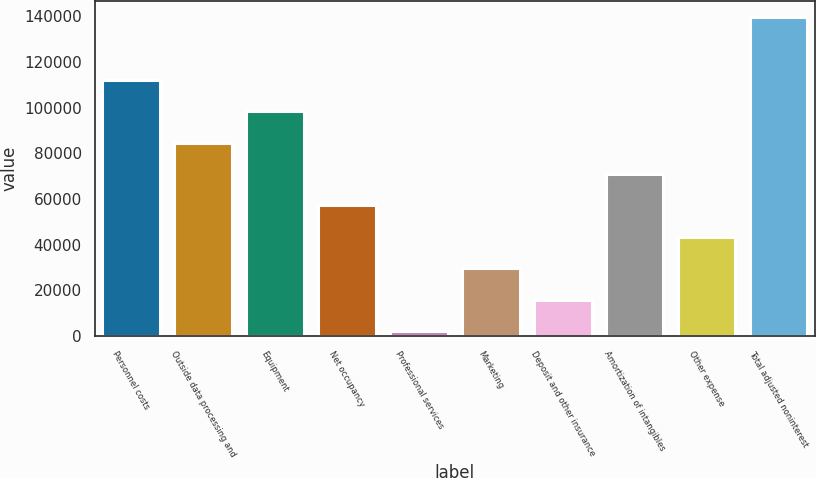Convert chart. <chart><loc_0><loc_0><loc_500><loc_500><bar_chart><fcel>Personnel costs<fcel>Outside data processing and<fcel>Equipment<fcel>Net occupancy<fcel>Professional services<fcel>Marketing<fcel>Deposit and other insurance<fcel>Amortization of intangibles<fcel>Other expense<fcel>Total adjusted noninterest<nl><fcel>112287<fcel>84757<fcel>98522<fcel>57227<fcel>2167<fcel>29697<fcel>15932<fcel>70992<fcel>43462<fcel>139817<nl></chart> 